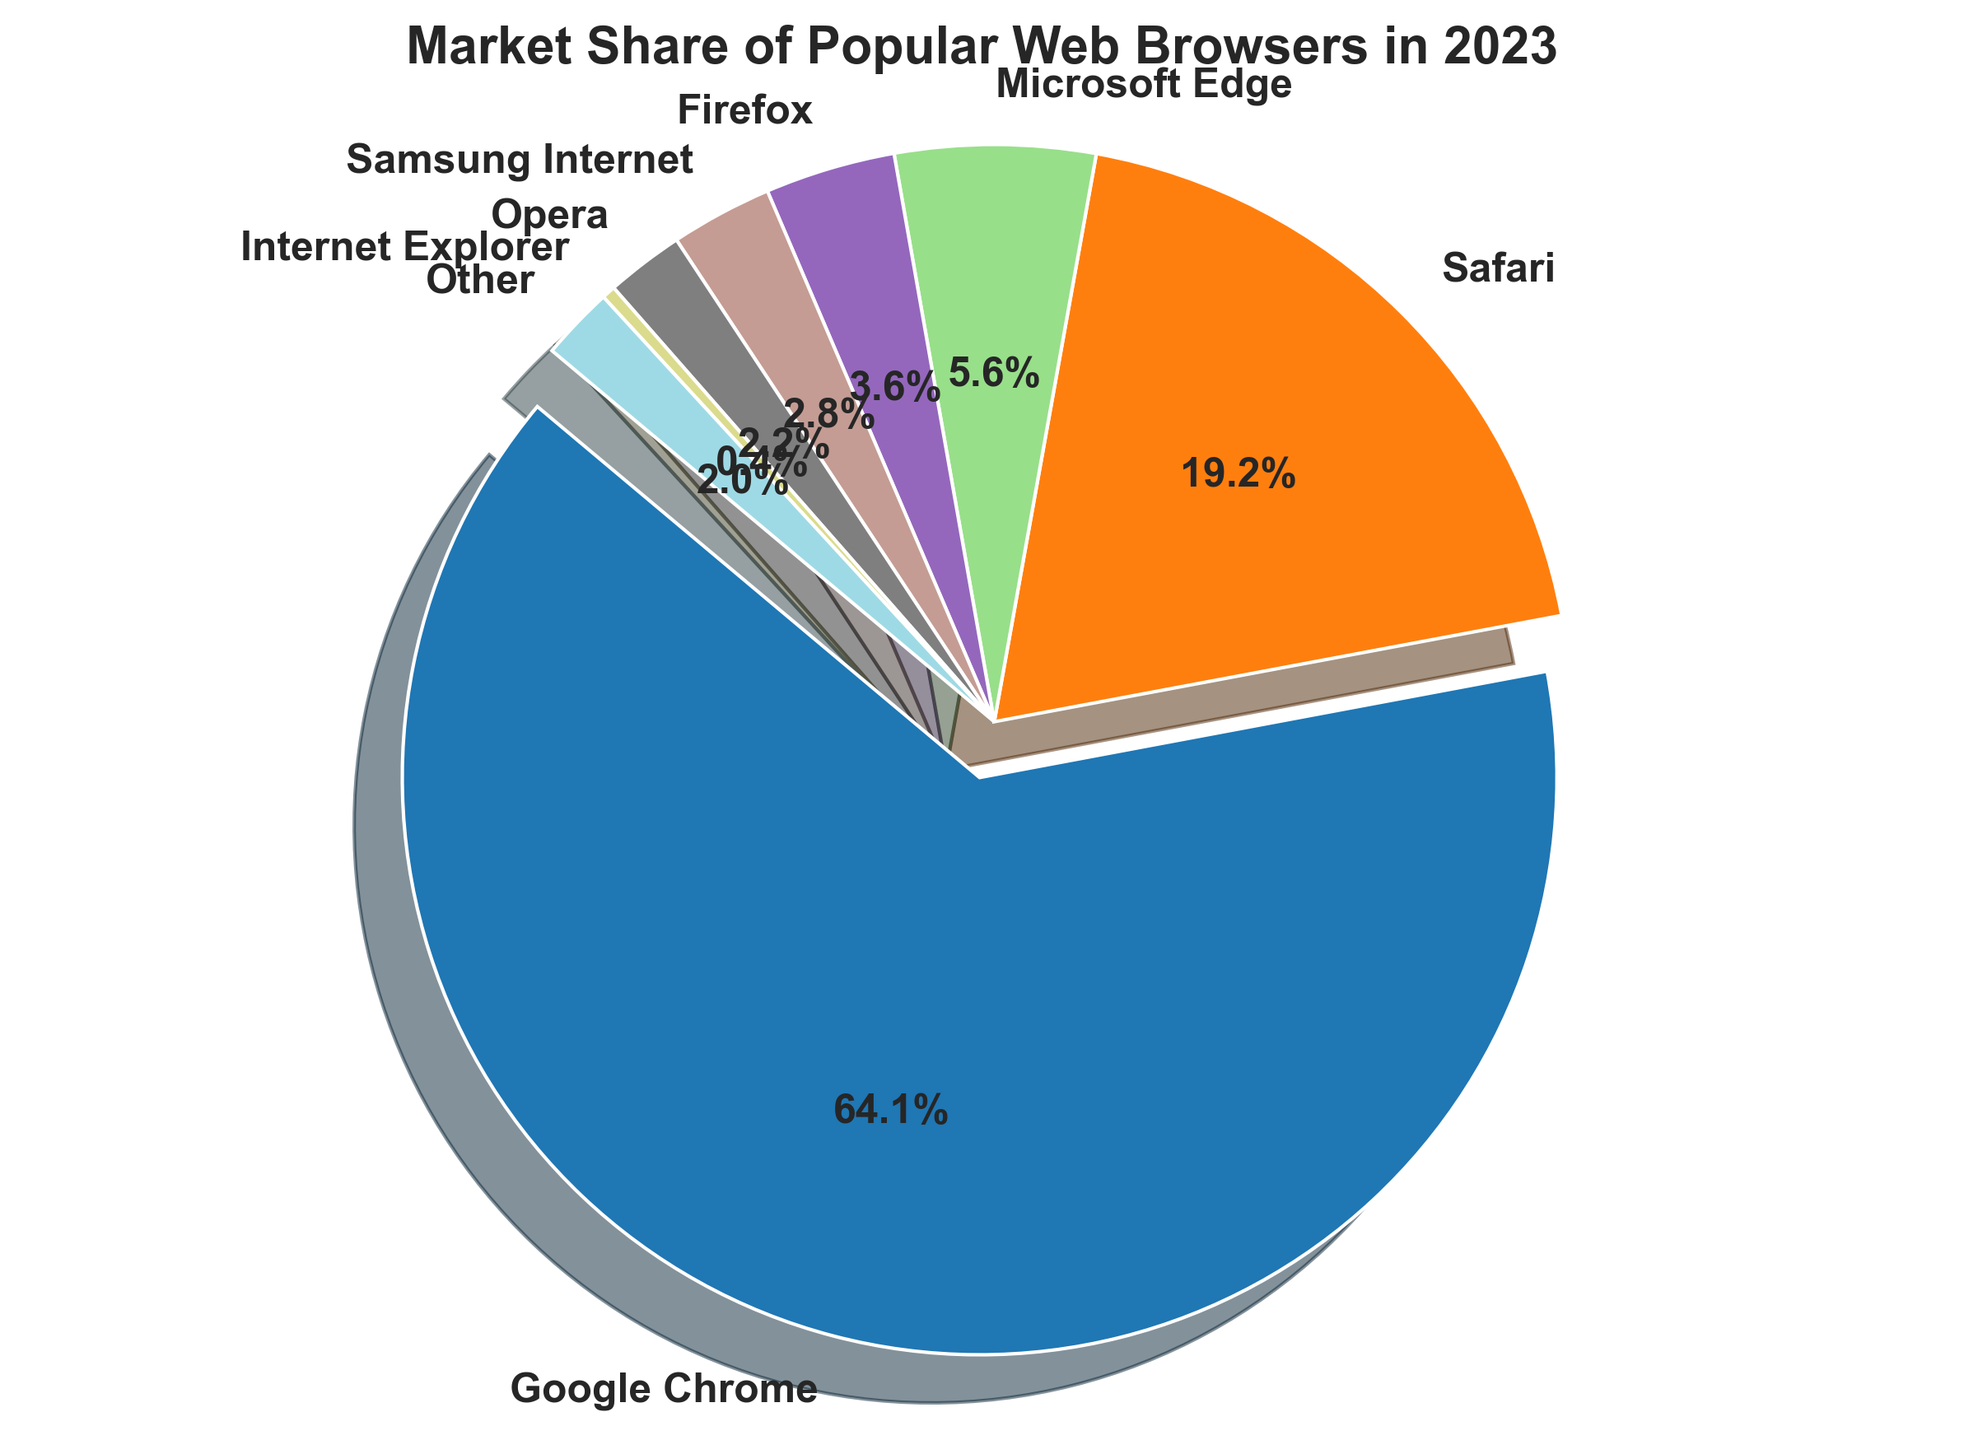Which web browser has the largest market share in 2023? Looking at the pie chart, the web browser with the most prominent segment is highlighted (exploded), which is Google Chrome.
Answer: Google Chrome How much more market share does Google Chrome have compared to Firefox? Google Chrome has a market share of 64.06%, and Firefox has 3.65%. Subtract Firefox's share from Chrome's share: 64.06% - 3.65% = 60.41%.
Answer: 60.41% What is the combined market share of Microsoft Edge and Internet Explorer? Summing the market shares for Microsoft Edge (5.61%) and Internet Explorer (0.38%): 5.61% + 0.38% = 5.99%.
Answer: 5.99% Is the market share of Safari greater than the combined market share of Samsung Internet and Opera? Safari has a market share of 19.22%. Combining Samsung Internet (2.85%) and Opera (2.18%) gives us 2.85% + 2.18% = 5.03%. Since 19.22% > 5.03%, Safari's market share is indeed greater.
Answer: Yes In terms of market share, how does Opera compare to Internet Explorer? Opera has a market share of 2.18%, while Internet Explorer has 0.38%. Since 2.18% > 0.38%, Opera's market share is higher than Internet Explorer's.
Answer: Opera's market share is higher What percentage of the market is occupied by browsers other than Google Chrome, Safari, and Microsoft Edge? Adding the market shares of Chrome, Safari, and Edge gives us: 64.06% (Chrome) + 19.22% (Safari) + 5.61% (Edge) = 88.89%. Subtracting this from 100% gives us the percentage for other browsers: 100% - 88.89% = 11.11%.
Answer: 11.11% Which web browser has the smallest market share, and what is it? The pie chart shows that Internet Explorer has the smallest segment, indicating the smallest market share at 0.38%.
Answer: Internet Explorer, 0.38% How much more market share does Safari need to reach a total of 25%? Safari currently has a 19.22% market share. To reach 25%, it needs an additional: 25% - 19.22% = 5.78%.
Answer: 5.78% If you combine the market shares of Firefox and other browsers, what is the total percentage? Adding the market shares for Firefox (3.65%) and Other (2.05%) gives us: 3.65% + 2.05% = 5.70%.
Answer: 5.70% Compare the market share of Samsung Internet to Opera. Which one is larger and by how much? Samsung Internet has a 2.85% market share, and Opera has 2.18%. The difference is 2.85% - 2.18% = 0.67%. Therefore, Samsung Internet's market share is larger by 0.67%.
Answer: Samsung Internet, 0.67% 